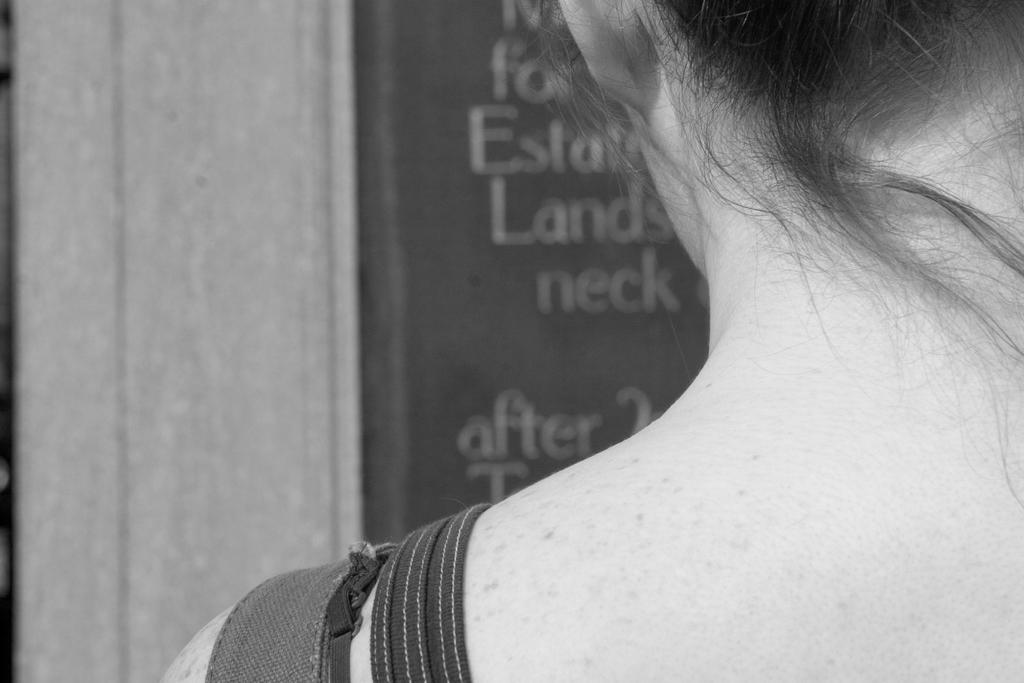What is the main subject of the image? The main subject of the image is a woman. What is the woman holding or interacting with in the image? There is a board with some text in the image. What type of scarf is the woman wearing in the image? There is no scarf visible in the image. How many cars can be seen in the image? There are no cars present in the image. 